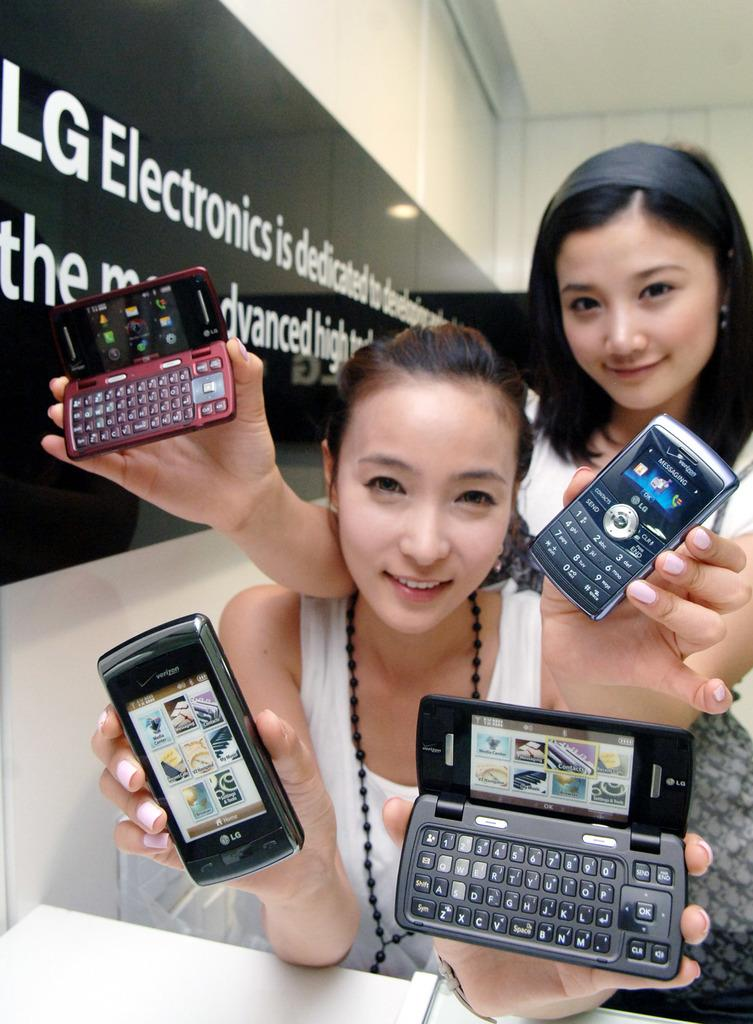<image>
Give a short and clear explanation of the subsequent image. a few people that have phones in their hand including an LG 